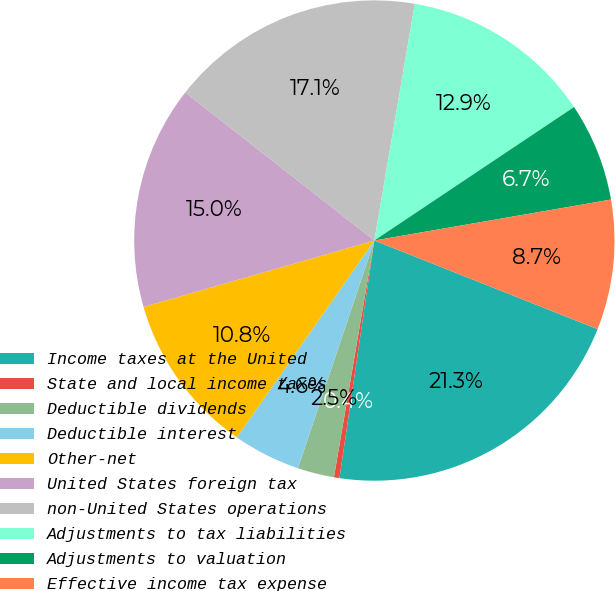Convert chart. <chart><loc_0><loc_0><loc_500><loc_500><pie_chart><fcel>Income taxes at the United<fcel>State and local income taxes<fcel>Deductible dividends<fcel>Deductible interest<fcel>Other-net<fcel>United States foreign tax<fcel>non-United States operations<fcel>Adjustments to tax liabilities<fcel>Adjustments to valuation<fcel>Effective income tax expense<nl><fcel>21.31%<fcel>0.37%<fcel>2.46%<fcel>4.55%<fcel>10.84%<fcel>15.03%<fcel>17.12%<fcel>12.93%<fcel>6.65%<fcel>8.74%<nl></chart> 